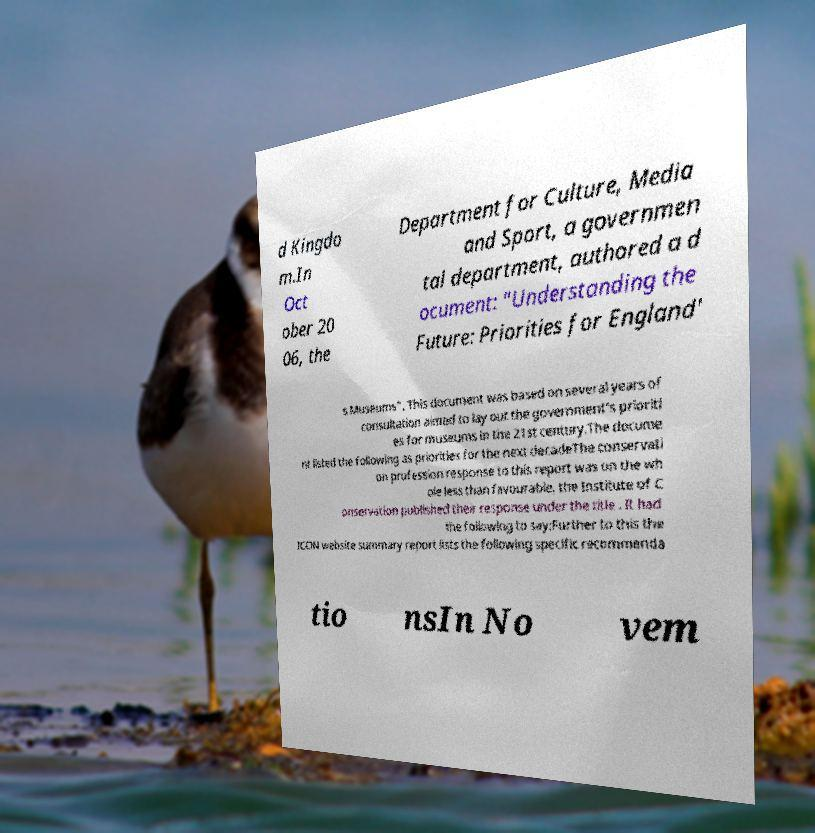What messages or text are displayed in this image? I need them in a readable, typed format. d Kingdo m.In Oct ober 20 06, the Department for Culture, Media and Sport, a governmen tal department, authored a d ocument: "Understanding the Future: Priorities for England' s Museums". This document was based on several years of consultation aimed to lay out the government's prioriti es for museums in the 21st century.The docume nt listed the following as priorities for the next decadeThe conservati on profession response to this report was on the wh ole less than favourable, the Institute of C onservation published their response under the title . It had the following to say:Further to this the ICON website summary report lists the following specific recommenda tio nsIn No vem 